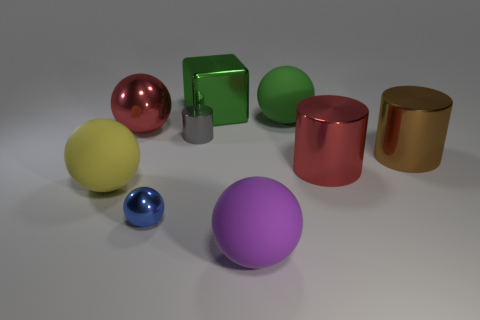What number of objects are either objects in front of the large metallic ball or big brown metal cylinders?
Your answer should be very brief. 6. What is the shape of the small gray thing that is made of the same material as the small sphere?
Provide a succinct answer. Cylinder. How many other big brown things have the same shape as the big brown metallic object?
Give a very brief answer. 0. What material is the purple thing?
Your response must be concise. Rubber. There is a large shiny block; is it the same color as the metal cylinder on the left side of the big green rubber ball?
Ensure brevity in your answer.  No. How many cubes are either large brown shiny things or large green rubber things?
Offer a terse response. 0. There is a small thing in front of the tiny metal cylinder; what is its color?
Offer a terse response. Blue. What shape is the thing that is the same color as the large block?
Make the answer very short. Sphere. What number of objects have the same size as the green matte ball?
Make the answer very short. 6. Do the big green thing that is in front of the big green metallic cube and the big red thing that is on the right side of the purple ball have the same shape?
Make the answer very short. No. 